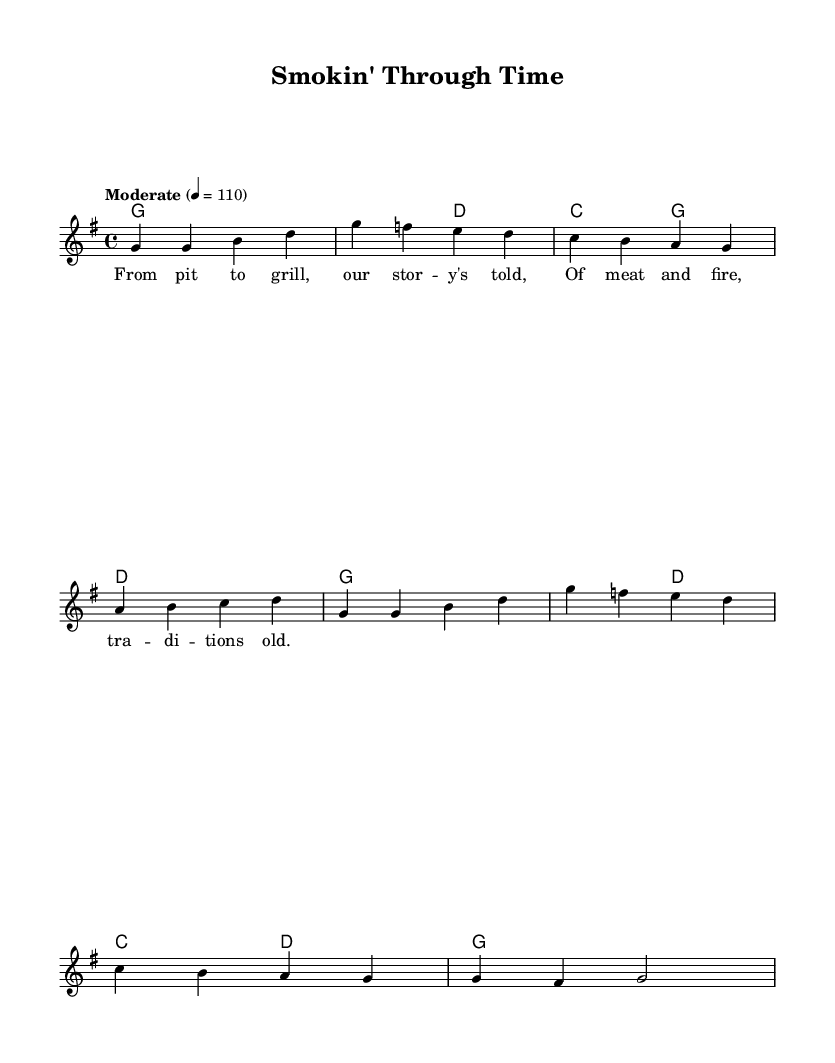What is the key signature of this music? The key signature is G major, which has one sharp (F#). This can be identified in the sheet music where the sharp is indicated at the beginning next to the clef sign.
Answer: G major What is the time signature of this piece? The time signature is 4/4, as indicated at the beginning of the sheet music. This means there are four beats in each measure, and the quarter note gets one beat.
Answer: 4/4 What is the tempo marking for this piece? The tempo marking is "Moderate," with a metronome indication of 110 beats per minute. This is found at the start of the music, indicating the intended speed of the song.
Answer: Moderate How many measures are present in the melody? There are eight measures in the melody section as shown by the grouping of notes and the bar lines that separate them throughout the piece.
Answer: Eight What theme does the lyrics of the song convey? The lyrics of the song convey the theme of barbecue and grilling history, emphasizing the traditional aspect of meat and fire, as indicated by the words in the verse.
Answer: Barbecue history What type of harmony is used in this folk song? The harmony used is primarily based on simple triads and root chords, which are characteristic of folk music, providing a straightforward accompaniment to the melody.
Answer: Triadic harmony Which musical form does this song seem to follow? The song follows a strophic form, where the verses repeat the same melody, typical of many folk songs, making it easy to sing along.
Answer: Strophic form 